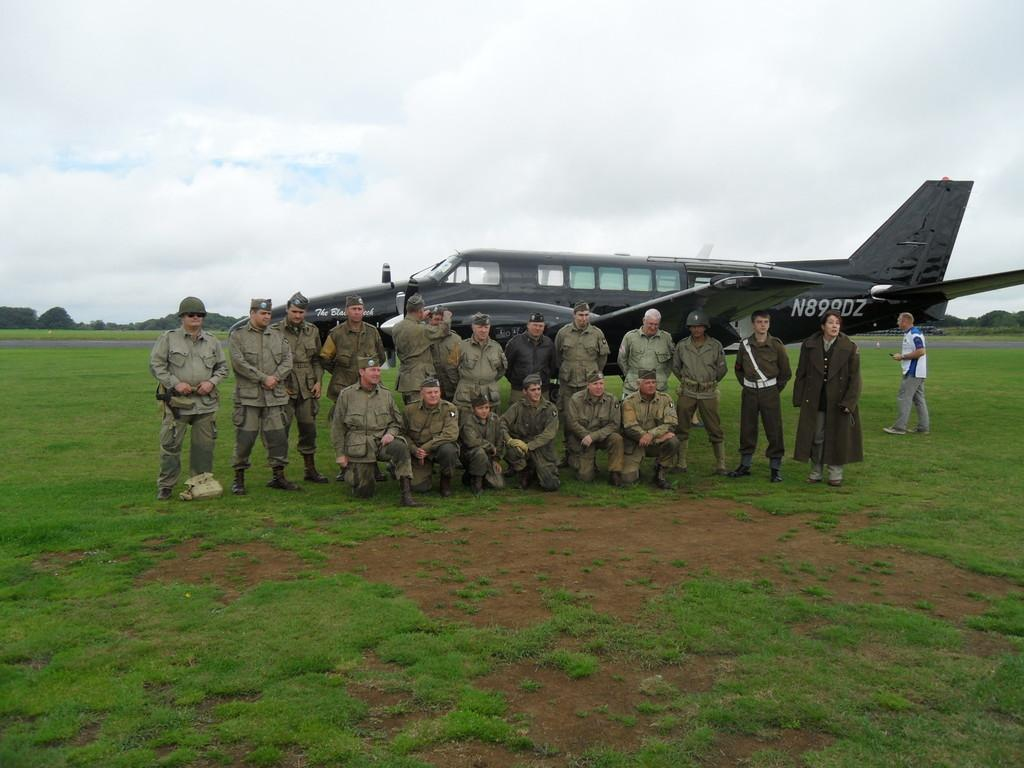<image>
Share a concise interpretation of the image provided. A group of Army men are posing in front of an aircraft with the number N899DZ on it. 